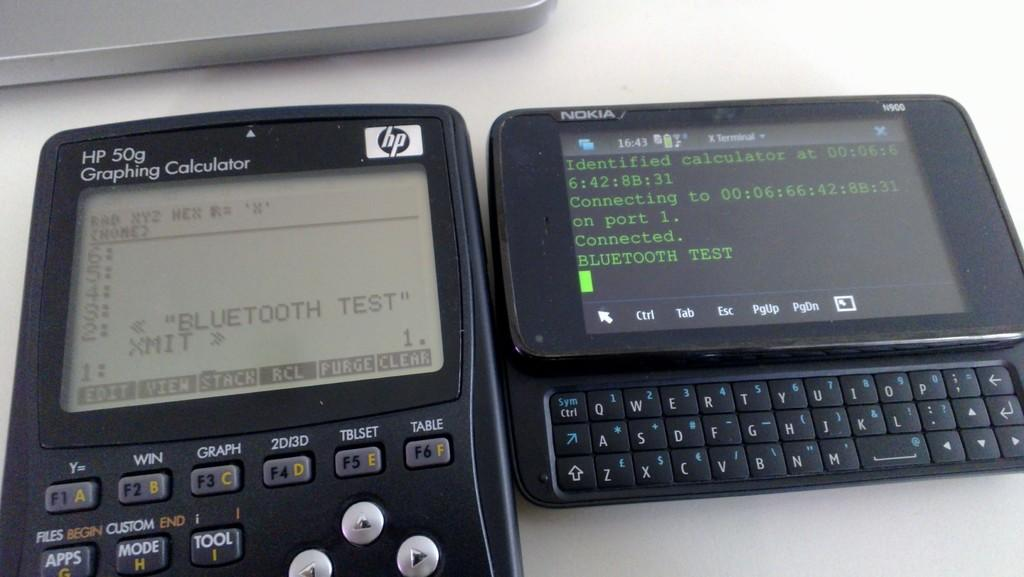Provide a one-sentence caption for the provided image. A black HP graphing calculator device beside an Nokia slide phone with the HP screen display featuring a Bluetooth test. 